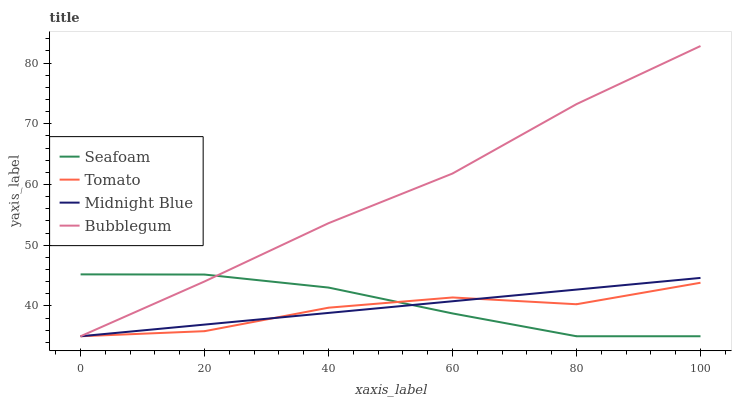Does Tomato have the minimum area under the curve?
Answer yes or no. Yes. Does Bubblegum have the maximum area under the curve?
Answer yes or no. Yes. Does Seafoam have the minimum area under the curve?
Answer yes or no. No. Does Seafoam have the maximum area under the curve?
Answer yes or no. No. Is Midnight Blue the smoothest?
Answer yes or no. Yes. Is Tomato the roughest?
Answer yes or no. Yes. Is Seafoam the smoothest?
Answer yes or no. No. Is Seafoam the roughest?
Answer yes or no. No. Does Tomato have the lowest value?
Answer yes or no. Yes. Does Bubblegum have the highest value?
Answer yes or no. Yes. Does Seafoam have the highest value?
Answer yes or no. No. Does Midnight Blue intersect Tomato?
Answer yes or no. Yes. Is Midnight Blue less than Tomato?
Answer yes or no. No. Is Midnight Blue greater than Tomato?
Answer yes or no. No. 